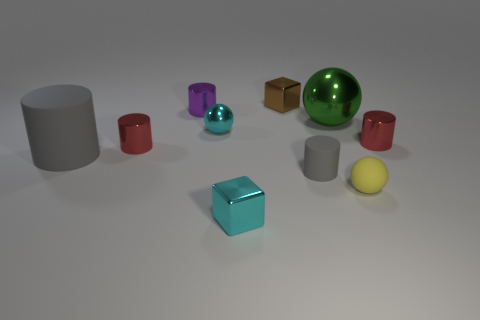Subtract 2 cylinders. How many cylinders are left? 3 Subtract all large gray cylinders. How many cylinders are left? 4 Subtract all yellow cylinders. Subtract all gray spheres. How many cylinders are left? 5 Subtract all spheres. How many objects are left? 7 Subtract 1 yellow spheres. How many objects are left? 9 Subtract all cyan blocks. Subtract all red cylinders. How many objects are left? 7 Add 5 rubber cylinders. How many rubber cylinders are left? 7 Add 3 tiny gray rubber balls. How many tiny gray rubber balls exist? 3 